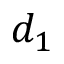<formula> <loc_0><loc_0><loc_500><loc_500>d _ { 1 }</formula> 